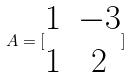<formula> <loc_0><loc_0><loc_500><loc_500>A = [ \begin{matrix} 1 & - 3 \\ 1 & 2 \end{matrix} ]</formula> 